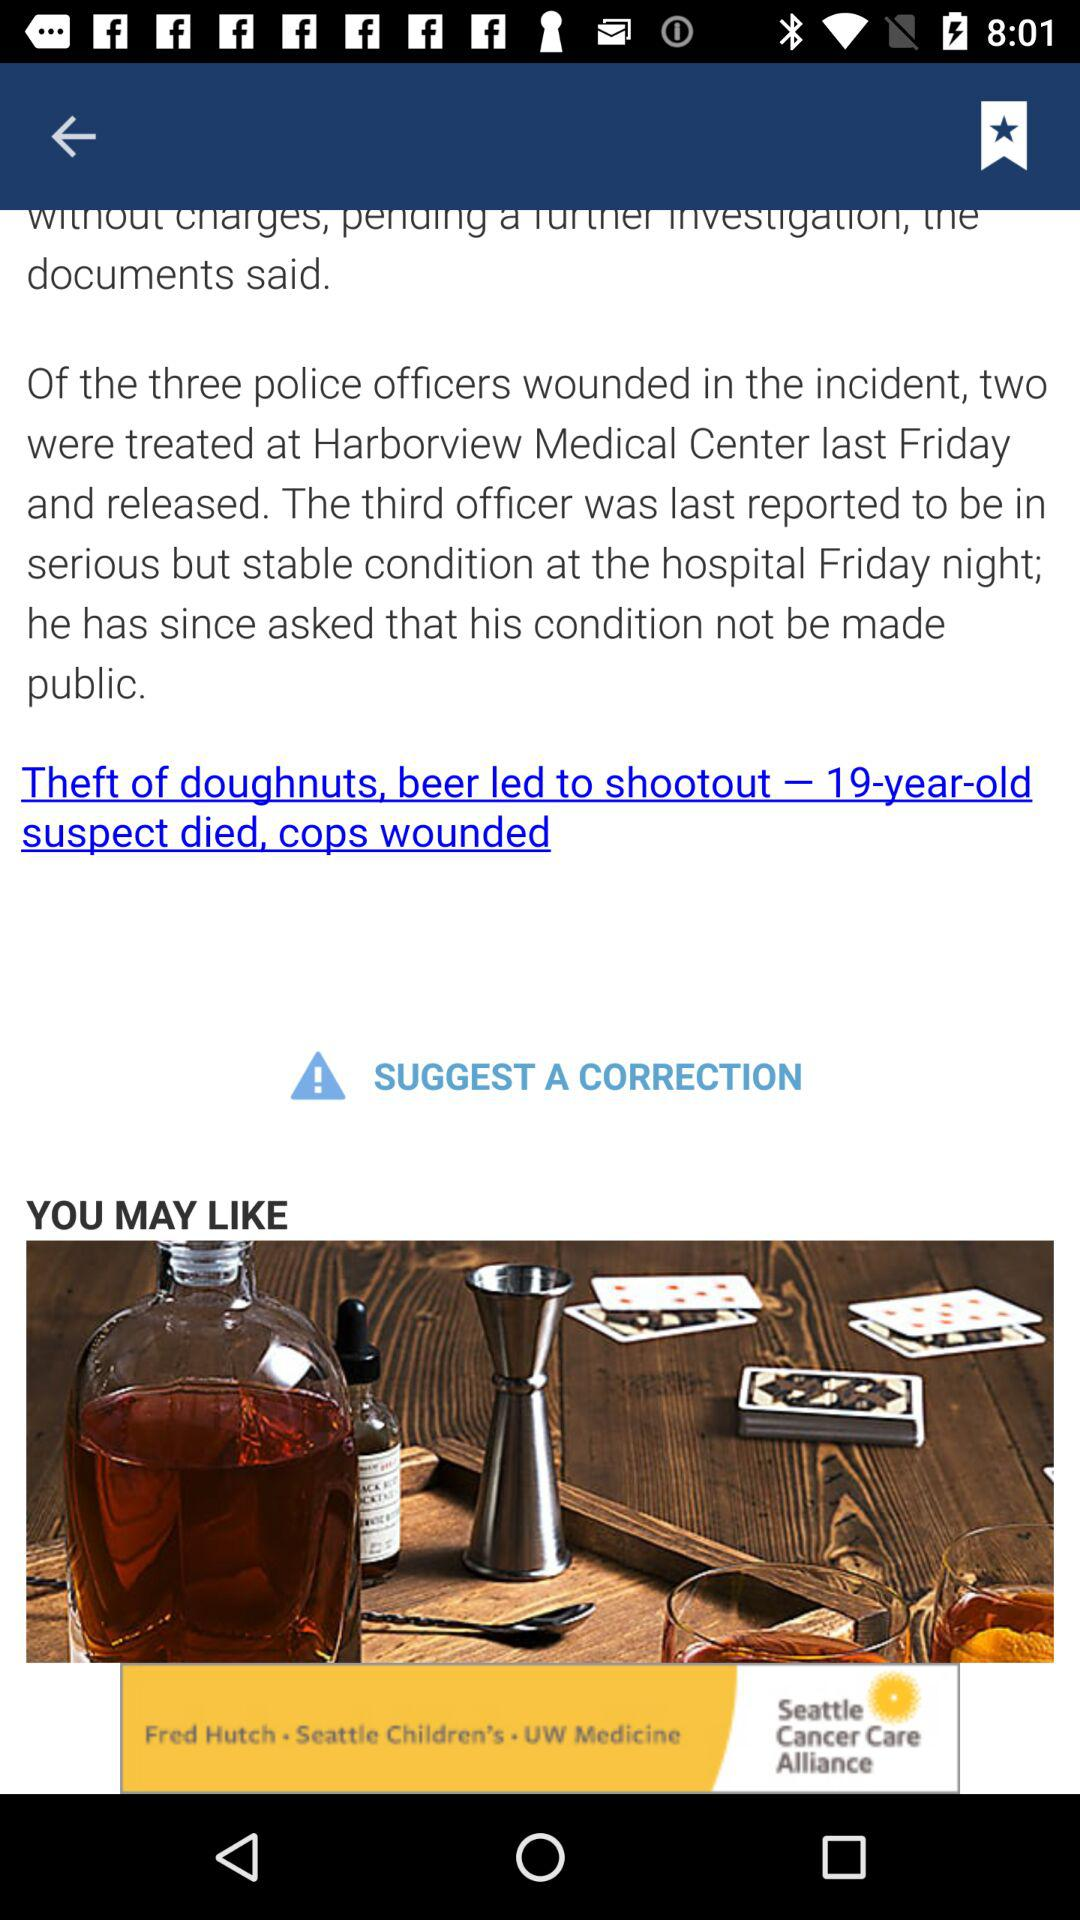What is the name of the hospital? The name of the hospital is "Harborview Medical Center". 